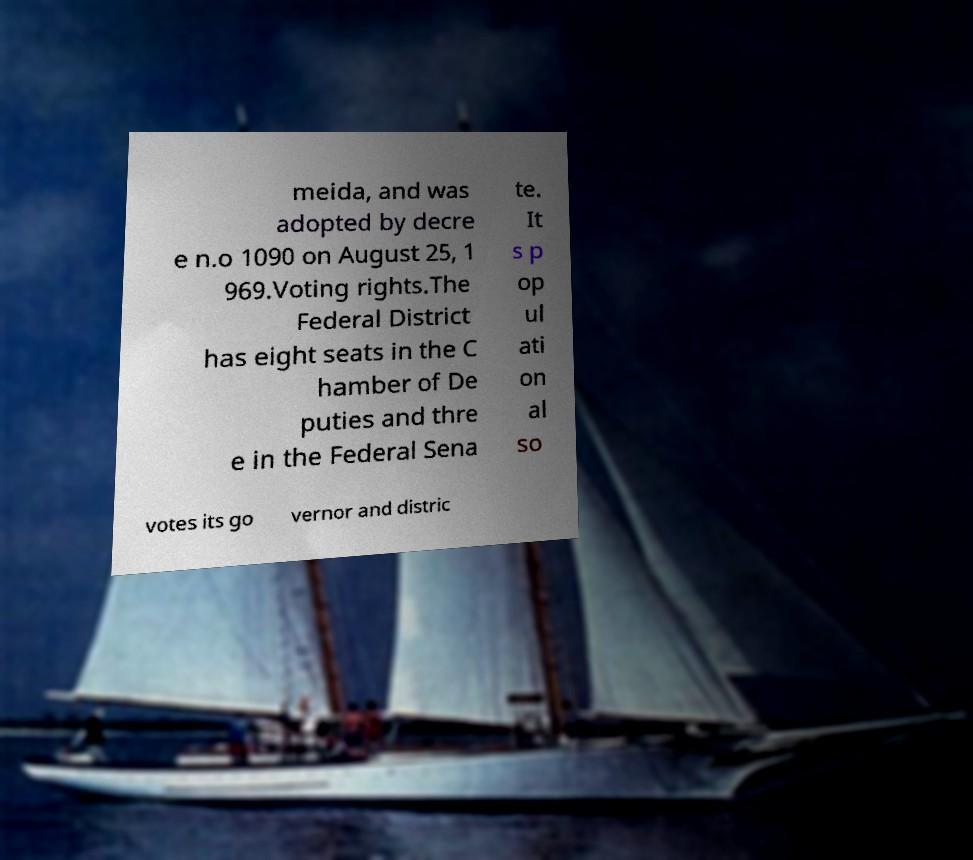What messages or text are displayed in this image? I need them in a readable, typed format. meida, and was adopted by decre e n.o 1090 on August 25, 1 969.Voting rights.The Federal District has eight seats in the C hamber of De puties and thre e in the Federal Sena te. It s p op ul ati on al so votes its go vernor and distric 